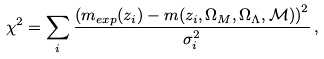Convert formula to latex. <formula><loc_0><loc_0><loc_500><loc_500>\chi ^ { 2 } = \sum _ { i } \frac { \left ( m _ { e x p } ( z _ { i } ) - m ( z _ { i } , \Omega _ { M } , \Omega _ { \Lambda } , \mathcal { M } ) \right ) ^ { 2 } } { \sigma _ { i } ^ { 2 } } \, ,</formula> 